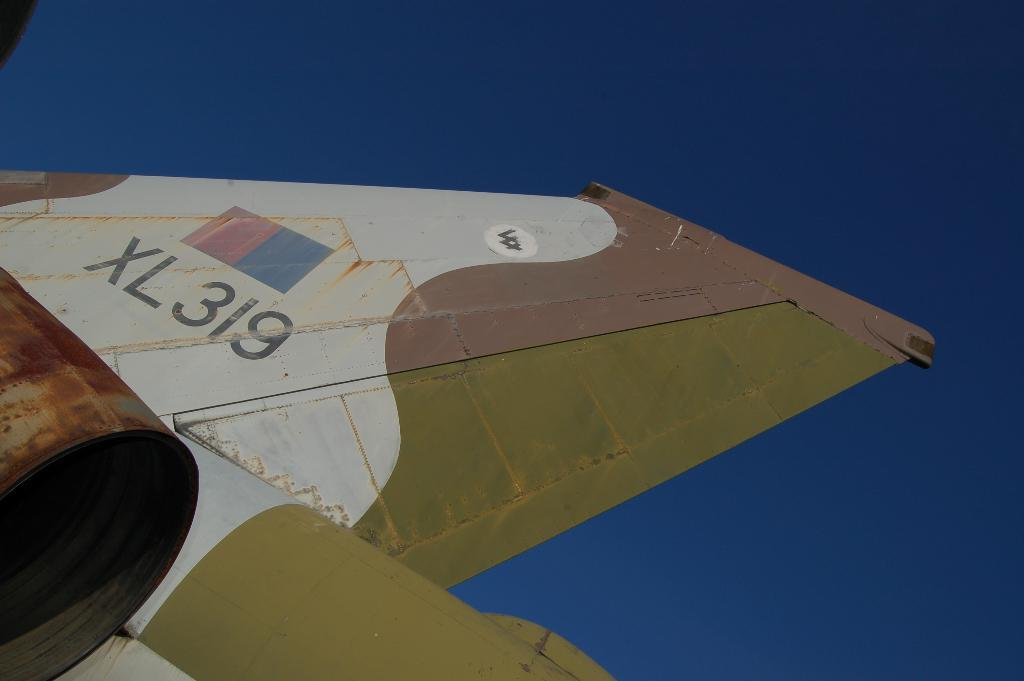<image>
Summarize the visual content of the image. Wing of an airplane in white tan and a goldish color with XL319 on the wing. 